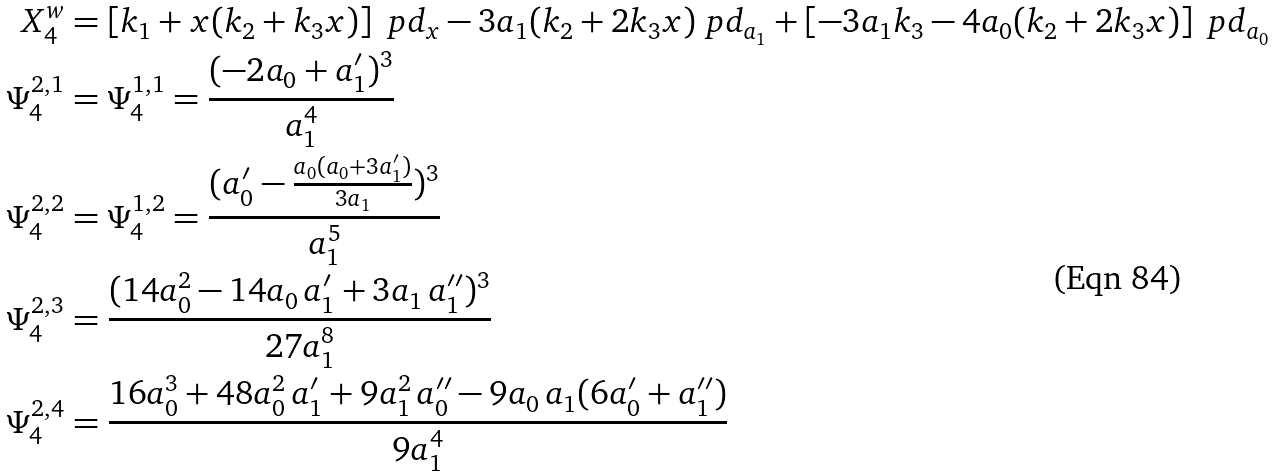<formula> <loc_0><loc_0><loc_500><loc_500>X _ { 4 } ^ { w } & = \left [ k _ { 1 } + x ( k _ { 2 } + k _ { 3 } x ) \right ] \ p d _ { x } - 3 a _ { 1 } ( k _ { 2 } + 2 k _ { 3 } x ) \ p d _ { a _ { 1 } } + \left [ - 3 a _ { 1 } k _ { 3 } - 4 a _ { 0 } ( k _ { 2 } + 2 k _ { 3 } x ) \right ] \ p d _ { a _ { 0 } } \\ \Psi _ { 4 } ^ { 2 , 1 } & = \Psi _ { 4 } ^ { 1 , 1 } = \frac { ( - 2 a _ { 0 } + a _ { 1 } ^ { \prime } ) ^ { 3 } } { a _ { 1 } ^ { 4 } } \\ \Psi _ { 4 } ^ { 2 , 2 } & = \Psi _ { 4 } ^ { 1 , 2 } = \frac { ( a _ { 0 } ^ { \prime } - \frac { a _ { 0 } ( a _ { 0 } + 3 a _ { 1 } ^ { \prime } ) } { 3 a _ { 1 } } ) ^ { 3 } } { a _ { 1 } ^ { 5 } } \\ \Psi _ { 4 } ^ { 2 , 3 } & = \frac { ( 1 4 a _ { 0 } ^ { 2 } - 1 4 a _ { 0 } \, a _ { 1 } ^ { \prime } + 3 a _ { 1 } \, a _ { 1 } ^ { \prime \prime } ) ^ { 3 } } { 2 7 a _ { 1 } ^ { 8 } } \\ \Psi _ { 4 } ^ { 2 , 4 } & = \frac { 1 6 a _ { 0 } ^ { 3 } + 4 8 a _ { 0 } ^ { 2 } \, a _ { 1 } ^ { \prime } + 9 a _ { 1 } ^ { 2 } \, a _ { 0 } ^ { \prime \prime } - 9 a _ { 0 } \, a _ { 1 } ( 6 a _ { 0 } ^ { \prime } + a _ { 1 } ^ { \prime \prime } ) } { 9 a _ { 1 } ^ { 4 } }</formula> 